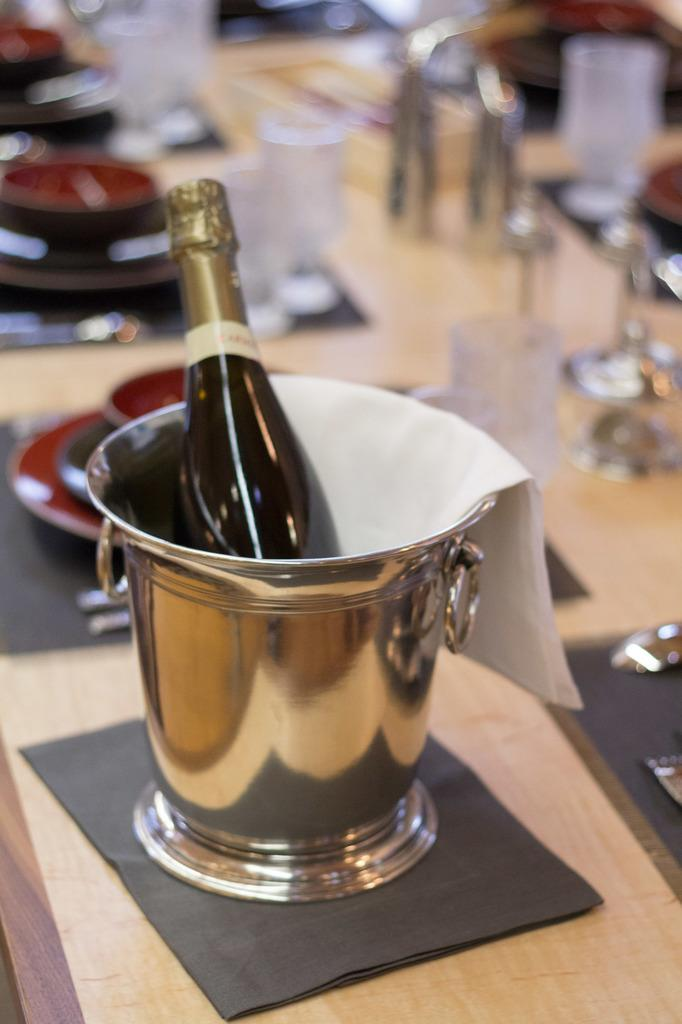What is in the steel bucket in the image? There is a wine bottle in the bucket. What else can be seen in the image besides the steel bucket and wine bottle? There are glasses in the background of the image. What is the temperature of the sea in the image? There is no sea present in the image, so it is not possible to determine the temperature. 